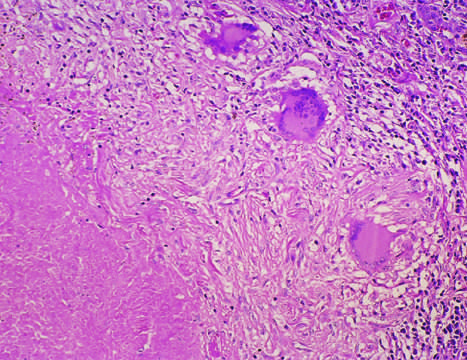what shows central granular caseation surrounded by epithelioid and multinucleate giant cells?
Answer the question using a single word or phrase. A characteristic tubercle 